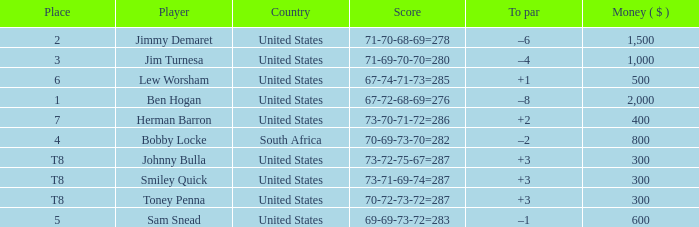What is the Money of the Player in Place 5? 600.0. 